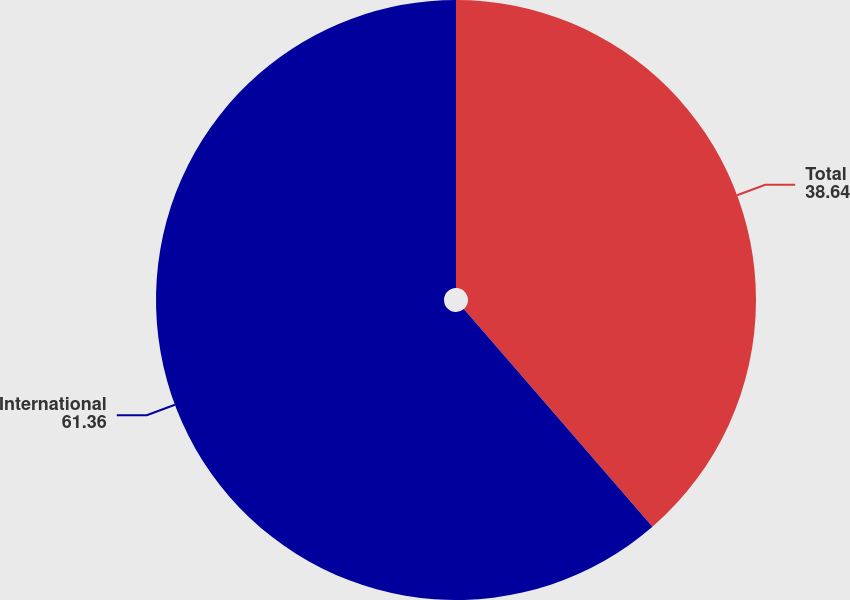Convert chart. <chart><loc_0><loc_0><loc_500><loc_500><pie_chart><fcel>Total<fcel>International<nl><fcel>38.64%<fcel>61.36%<nl></chart> 